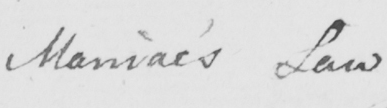What is written in this line of handwriting? Maniac ' s Law 